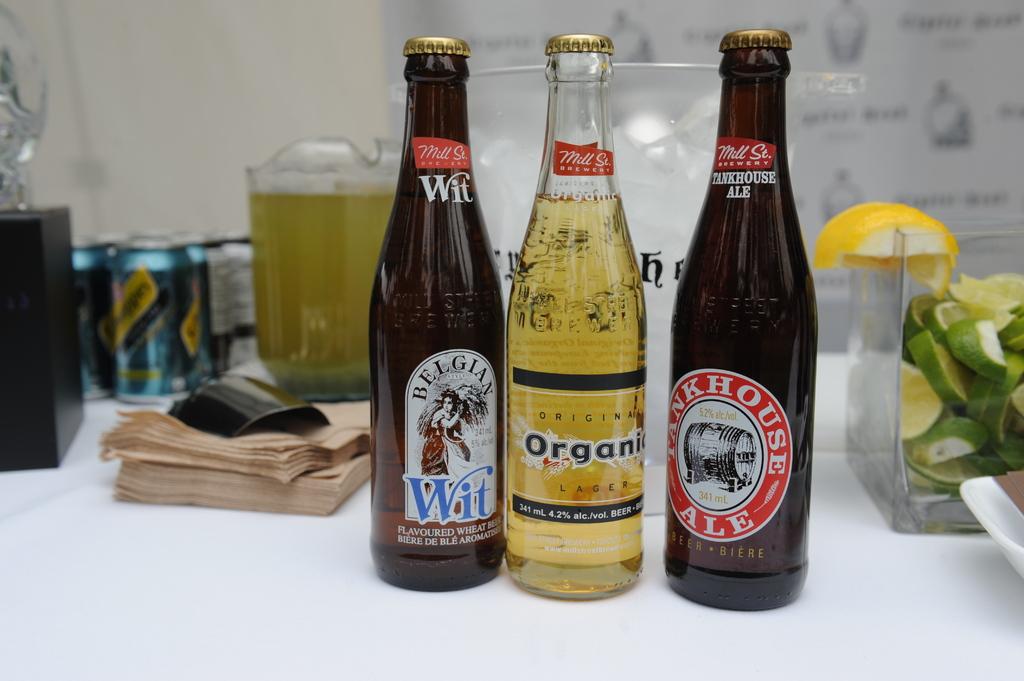What strength is the beer in the middle?
Your answer should be compact. 4.2%. What type of beer is the bottle on the left?
Provide a short and direct response. Belgian wit. 